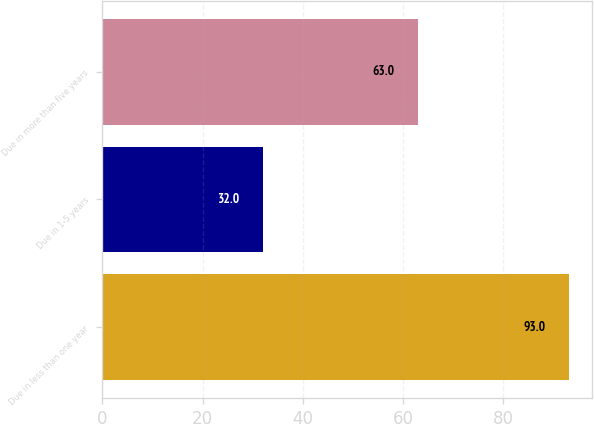Convert chart to OTSL. <chart><loc_0><loc_0><loc_500><loc_500><bar_chart><fcel>Due in less than one year<fcel>Due in 1-5 years<fcel>Due in more than five years<nl><fcel>93<fcel>32<fcel>63<nl></chart> 